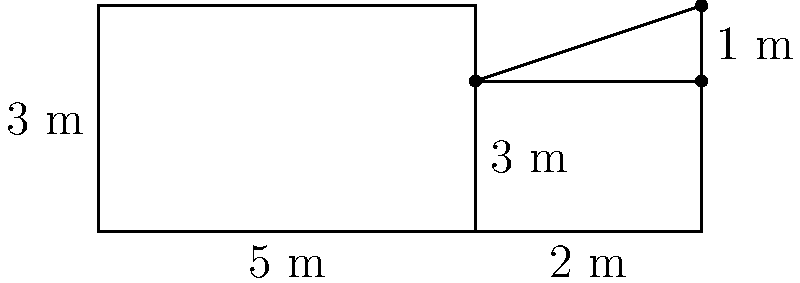A new educational tablet app displays the following composite shape on its screen. The shape consists of two rectangles and a right triangle. Calculate the total area of this composite shape. How does this digital representation enhance students' understanding of area calculations compared to traditional methods? Let's break down the problem step-by-step:

1. Identify the shapes:
   - Rectangle 1: 5m x 3m
   - Rectangle 2: 3m x 2m
   - Right triangle: base 3m, height 1m

2. Calculate the area of Rectangle 1:
   $A_1 = 5m \times 3m = 15m^2$

3. Calculate the area of Rectangle 2:
   $A_2 = 3m \times 2m = 6m^2$

4. Calculate the area of the right triangle:
   $A_3 = \frac{1}{2} \times base \times height = \frac{1}{2} \times 3m \times 1m = 1.5m^2$

5. Sum up the areas to get the total area:
   $A_{total} = A_1 + A_2 + A_3 = 15m^2 + 6m^2 + 1.5m^2 = 22.5m^2$

This digital representation enhances students' understanding of area calculations in several ways:

1. Visual clarity: The tablet screen provides a clear, precise representation of the shape, making it easier for students to identify individual components.

2. Interactive potential: Students can potentially manipulate the shape, resize it, or break it apart to better understand how composite shapes are formed.

3. Immediate feedback: Digital tools can provide instant verification of calculations, allowing students to check their work and learn from mistakes quickly.

4. Scalability: The app can easily generate multiple problems with varying complexity, adapting to different skill levels.

5. Real-world connection: Digital representation mimics how shapes might be presented in modern professional settings, preparing students for future applications.
Answer: $22.5m^2$ 